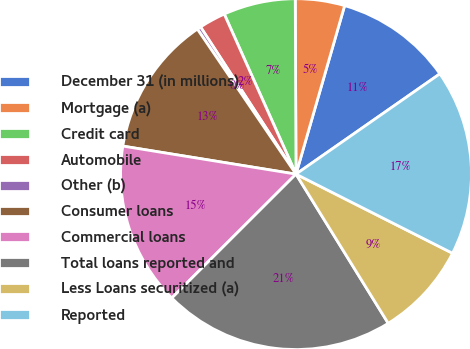Convert chart to OTSL. <chart><loc_0><loc_0><loc_500><loc_500><pie_chart><fcel>December 31 (in millions)<fcel>Mortgage (a)<fcel>Credit card<fcel>Automobile<fcel>Other (b)<fcel>Consumer loans<fcel>Commercial loans<fcel>Total loans reported and<fcel>Less Loans securitized (a)<fcel>Reported<nl><fcel>10.84%<fcel>4.54%<fcel>6.64%<fcel>2.45%<fcel>0.35%<fcel>12.94%<fcel>15.04%<fcel>21.33%<fcel>8.74%<fcel>17.14%<nl></chart> 